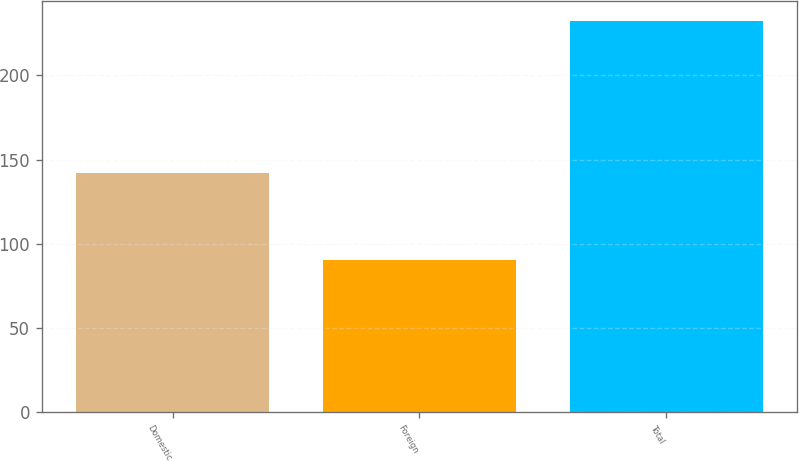<chart> <loc_0><loc_0><loc_500><loc_500><bar_chart><fcel>Domestic<fcel>Foreign<fcel>Total<nl><fcel>141.9<fcel>90.5<fcel>232.4<nl></chart> 